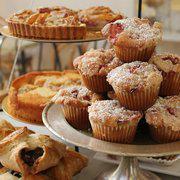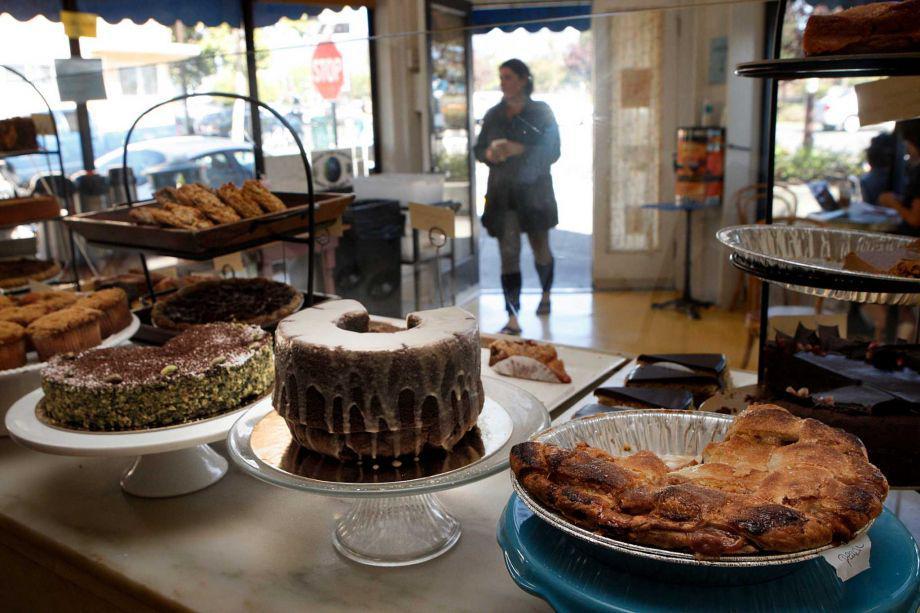The first image is the image on the left, the second image is the image on the right. For the images shown, is this caption "There are a multiple baked goods per image, exposed to open air." true? Answer yes or no. Yes. The first image is the image on the left, the second image is the image on the right. Assess this claim about the two images: "Pastries have yellow labels in one of the images.". Correct or not? Answer yes or no. No. 